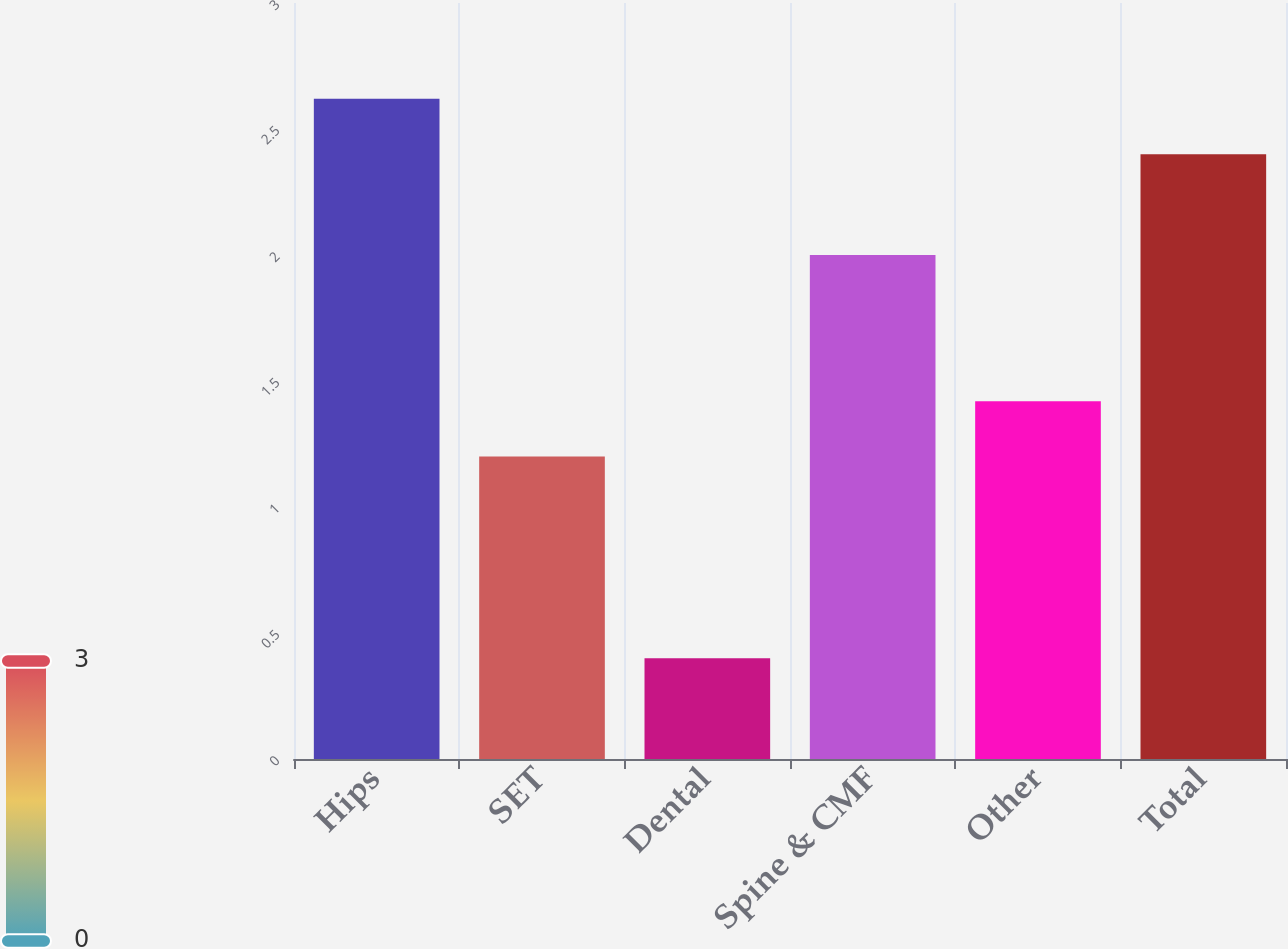Convert chart. <chart><loc_0><loc_0><loc_500><loc_500><bar_chart><fcel>Hips<fcel>SET<fcel>Dental<fcel>Spine & CMF<fcel>Other<fcel>Total<nl><fcel>2.62<fcel>1.2<fcel>0.4<fcel>2<fcel>1.42<fcel>2.4<nl></chart> 